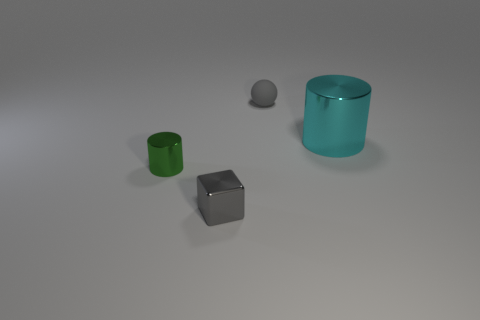Add 1 large shiny things. How many objects exist? 5 Subtract all balls. How many objects are left? 3 Subtract all tiny red metal blocks. Subtract all cyan cylinders. How many objects are left? 3 Add 4 small gray blocks. How many small gray blocks are left? 5 Add 4 small green spheres. How many small green spheres exist? 4 Subtract 0 brown balls. How many objects are left? 4 